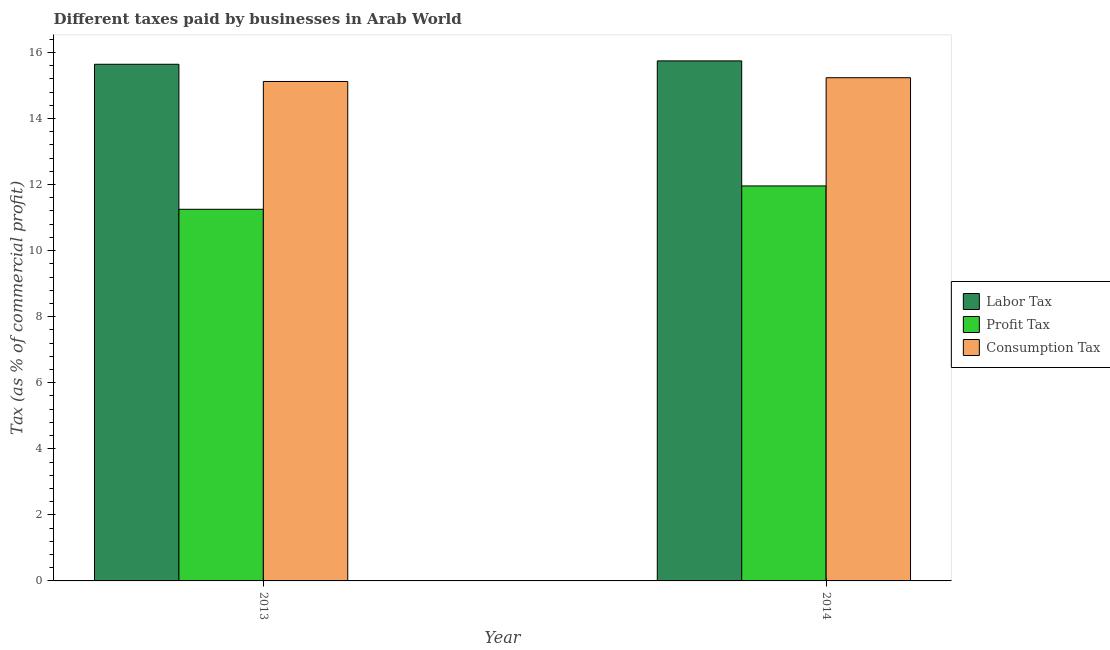How many different coloured bars are there?
Your answer should be compact. 3. How many bars are there on the 2nd tick from the left?
Your answer should be very brief. 3. How many bars are there on the 1st tick from the right?
Offer a very short reply. 3. What is the percentage of profit tax in 2013?
Provide a succinct answer. 11.25. Across all years, what is the maximum percentage of consumption tax?
Provide a succinct answer. 15.23. Across all years, what is the minimum percentage of labor tax?
Provide a succinct answer. 15.64. What is the total percentage of profit tax in the graph?
Give a very brief answer. 23.21. What is the difference between the percentage of consumption tax in 2013 and that in 2014?
Your response must be concise. -0.11. What is the difference between the percentage of labor tax in 2013 and the percentage of profit tax in 2014?
Your response must be concise. -0.1. What is the average percentage of labor tax per year?
Provide a short and direct response. 15.69. In how many years, is the percentage of labor tax greater than 11.2 %?
Provide a succinct answer. 2. What is the ratio of the percentage of profit tax in 2013 to that in 2014?
Give a very brief answer. 0.94. Is the percentage of consumption tax in 2013 less than that in 2014?
Offer a very short reply. Yes. In how many years, is the percentage of profit tax greater than the average percentage of profit tax taken over all years?
Provide a succinct answer. 1. What does the 1st bar from the left in 2013 represents?
Offer a terse response. Labor Tax. What does the 3rd bar from the right in 2013 represents?
Your response must be concise. Labor Tax. Is it the case that in every year, the sum of the percentage of labor tax and percentage of profit tax is greater than the percentage of consumption tax?
Ensure brevity in your answer.  Yes. How many years are there in the graph?
Your answer should be compact. 2. Are the values on the major ticks of Y-axis written in scientific E-notation?
Keep it short and to the point. No. Does the graph contain grids?
Provide a succinct answer. No. Where does the legend appear in the graph?
Offer a very short reply. Center right. What is the title of the graph?
Your answer should be very brief. Different taxes paid by businesses in Arab World. Does "Transport" appear as one of the legend labels in the graph?
Offer a very short reply. No. What is the label or title of the X-axis?
Provide a short and direct response. Year. What is the label or title of the Y-axis?
Make the answer very short. Tax (as % of commercial profit). What is the Tax (as % of commercial profit) of Labor Tax in 2013?
Provide a succinct answer. 15.64. What is the Tax (as % of commercial profit) in Profit Tax in 2013?
Offer a terse response. 11.25. What is the Tax (as % of commercial profit) in Consumption Tax in 2013?
Your response must be concise. 15.12. What is the Tax (as % of commercial profit) of Labor Tax in 2014?
Offer a very short reply. 15.74. What is the Tax (as % of commercial profit) of Profit Tax in 2014?
Make the answer very short. 11.96. What is the Tax (as % of commercial profit) of Consumption Tax in 2014?
Your answer should be compact. 15.23. Across all years, what is the maximum Tax (as % of commercial profit) in Labor Tax?
Provide a succinct answer. 15.74. Across all years, what is the maximum Tax (as % of commercial profit) in Profit Tax?
Give a very brief answer. 11.96. Across all years, what is the maximum Tax (as % of commercial profit) of Consumption Tax?
Ensure brevity in your answer.  15.23. Across all years, what is the minimum Tax (as % of commercial profit) of Labor Tax?
Give a very brief answer. 15.64. Across all years, what is the minimum Tax (as % of commercial profit) of Profit Tax?
Ensure brevity in your answer.  11.25. Across all years, what is the minimum Tax (as % of commercial profit) in Consumption Tax?
Keep it short and to the point. 15.12. What is the total Tax (as % of commercial profit) in Labor Tax in the graph?
Your answer should be very brief. 31.38. What is the total Tax (as % of commercial profit) of Profit Tax in the graph?
Make the answer very short. 23.21. What is the total Tax (as % of commercial profit) in Consumption Tax in the graph?
Your response must be concise. 30.35. What is the difference between the Tax (as % of commercial profit) of Labor Tax in 2013 and that in 2014?
Offer a terse response. -0.1. What is the difference between the Tax (as % of commercial profit) in Profit Tax in 2013 and that in 2014?
Your response must be concise. -0.71. What is the difference between the Tax (as % of commercial profit) in Consumption Tax in 2013 and that in 2014?
Your answer should be very brief. -0.11. What is the difference between the Tax (as % of commercial profit) in Labor Tax in 2013 and the Tax (as % of commercial profit) in Profit Tax in 2014?
Make the answer very short. 3.68. What is the difference between the Tax (as % of commercial profit) of Labor Tax in 2013 and the Tax (as % of commercial profit) of Consumption Tax in 2014?
Keep it short and to the point. 0.41. What is the difference between the Tax (as % of commercial profit) of Profit Tax in 2013 and the Tax (as % of commercial profit) of Consumption Tax in 2014?
Your answer should be very brief. -3.98. What is the average Tax (as % of commercial profit) in Labor Tax per year?
Provide a short and direct response. 15.69. What is the average Tax (as % of commercial profit) in Profit Tax per year?
Give a very brief answer. 11.6. What is the average Tax (as % of commercial profit) of Consumption Tax per year?
Your answer should be very brief. 15.18. In the year 2013, what is the difference between the Tax (as % of commercial profit) in Labor Tax and Tax (as % of commercial profit) in Profit Tax?
Your response must be concise. 4.39. In the year 2013, what is the difference between the Tax (as % of commercial profit) in Labor Tax and Tax (as % of commercial profit) in Consumption Tax?
Keep it short and to the point. 0.52. In the year 2013, what is the difference between the Tax (as % of commercial profit) in Profit Tax and Tax (as % of commercial profit) in Consumption Tax?
Your answer should be compact. -3.87. In the year 2014, what is the difference between the Tax (as % of commercial profit) of Labor Tax and Tax (as % of commercial profit) of Profit Tax?
Give a very brief answer. 3.79. In the year 2014, what is the difference between the Tax (as % of commercial profit) of Labor Tax and Tax (as % of commercial profit) of Consumption Tax?
Your response must be concise. 0.51. In the year 2014, what is the difference between the Tax (as % of commercial profit) of Profit Tax and Tax (as % of commercial profit) of Consumption Tax?
Give a very brief answer. -3.28. What is the ratio of the Tax (as % of commercial profit) of Profit Tax in 2013 to that in 2014?
Keep it short and to the point. 0.94. What is the difference between the highest and the second highest Tax (as % of commercial profit) of Labor Tax?
Make the answer very short. 0.1. What is the difference between the highest and the second highest Tax (as % of commercial profit) of Profit Tax?
Your answer should be compact. 0.71. What is the difference between the highest and the second highest Tax (as % of commercial profit) in Consumption Tax?
Ensure brevity in your answer.  0.11. What is the difference between the highest and the lowest Tax (as % of commercial profit) in Labor Tax?
Your response must be concise. 0.1. What is the difference between the highest and the lowest Tax (as % of commercial profit) in Profit Tax?
Provide a short and direct response. 0.71. What is the difference between the highest and the lowest Tax (as % of commercial profit) of Consumption Tax?
Your answer should be compact. 0.11. 